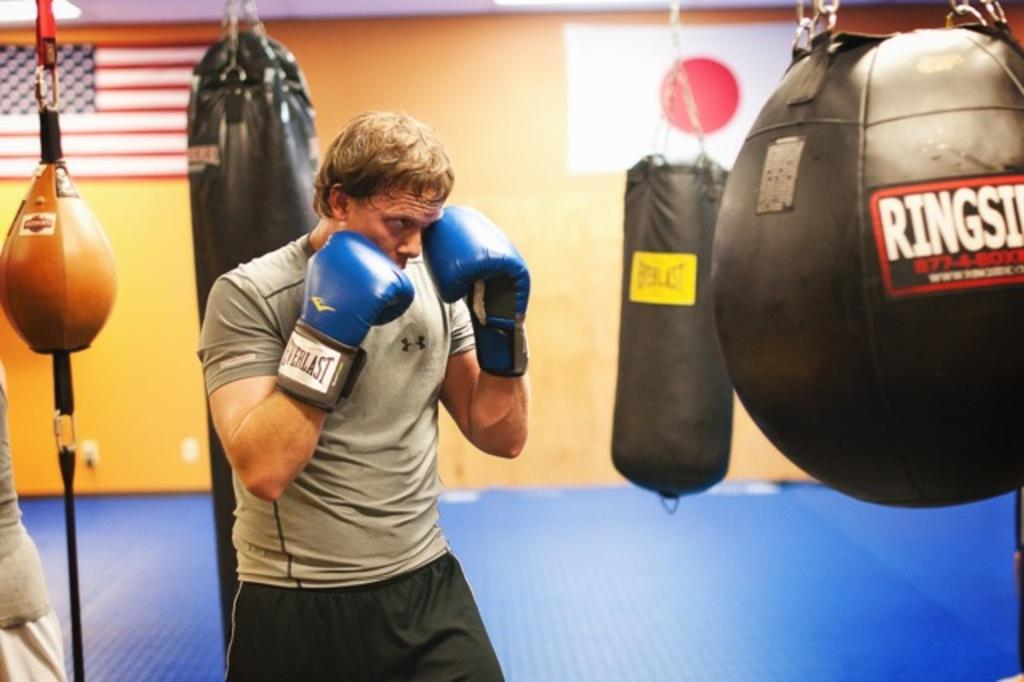<image>
Render a clear and concise summary of the photo. man with blue everlast boxing gloves in gym  with everlast and rigside punching bags and american flag on the wall 